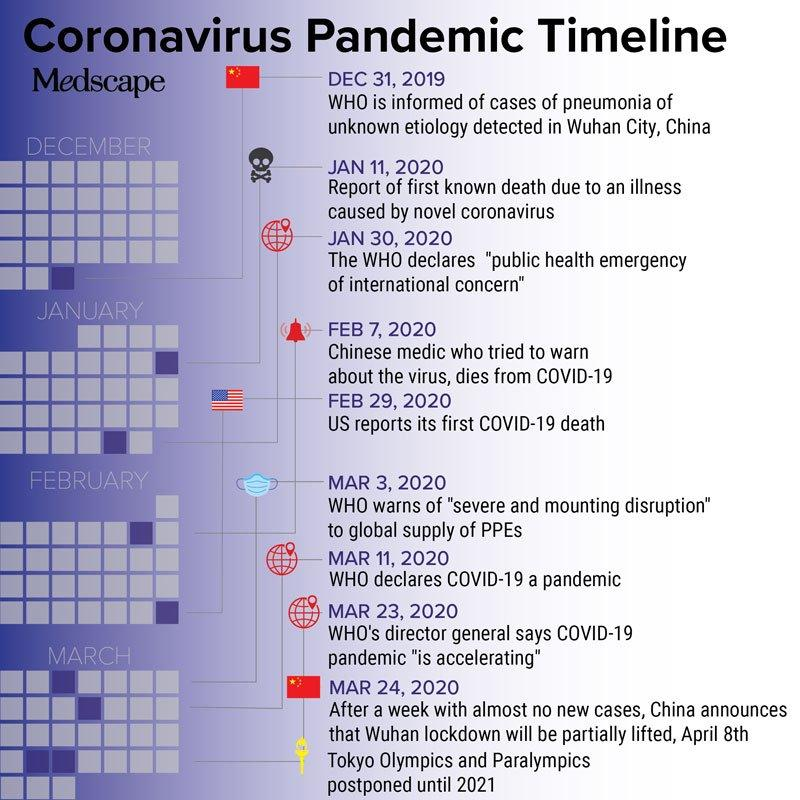List a handful of essential elements in this visual. The United States reported its first COVID-19 death on February 29, 2020. The World Health Organization declared COVID-19 a global pandemic on March 11, 2020. 